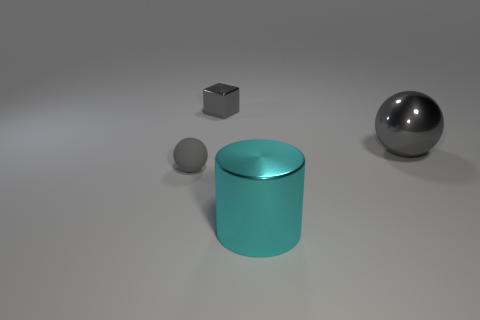Subtract all purple cylinders. Subtract all red cubes. How many cylinders are left? 1 Add 3 small gray balls. How many objects exist? 7 Subtract all cylinders. How many objects are left? 3 Add 1 cubes. How many cubes exist? 2 Subtract 0 blue blocks. How many objects are left? 4 Subtract all cyan shiny cylinders. Subtract all metallic cubes. How many objects are left? 2 Add 2 large gray shiny things. How many large gray shiny things are left? 3 